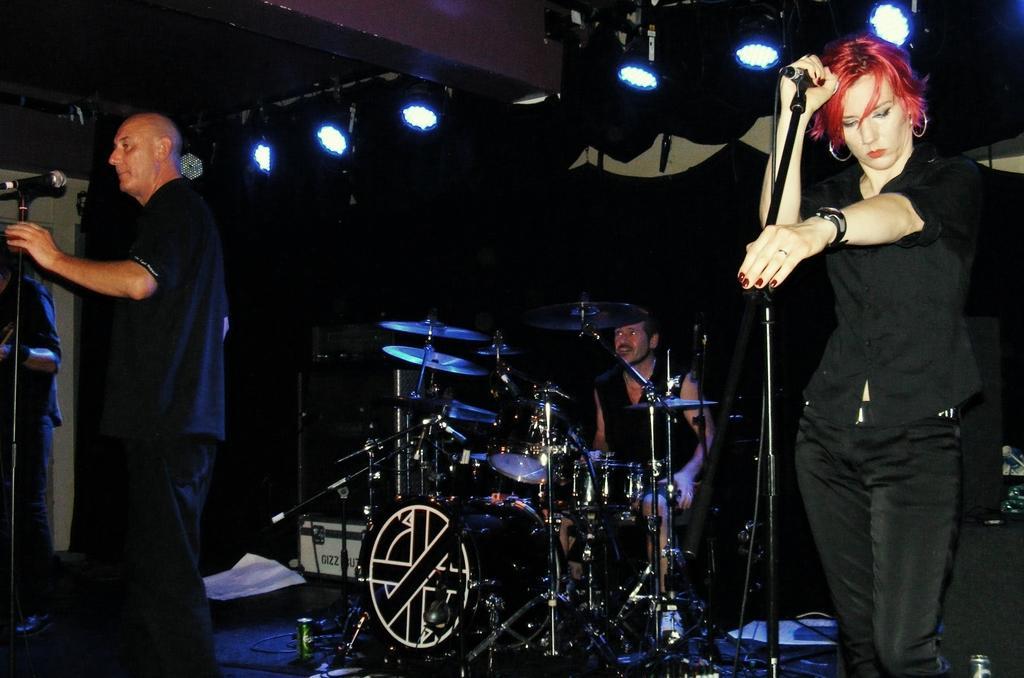Please provide a concise description of this image. In the image we can see a woman and a man standing and another man is sitting. They are wearing clothes, the woman is wearing a wrist watch and earrings. Here we can see musical instruments, microphone to the stand, cable wires and the lights. 